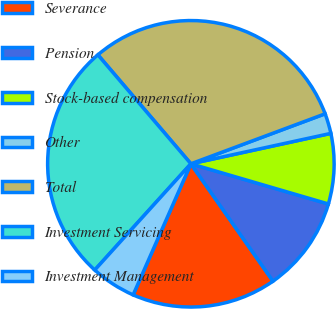<chart> <loc_0><loc_0><loc_500><loc_500><pie_chart><fcel>Severance<fcel>Pension<fcel>Stock-based compensation<fcel>Other<fcel>Total<fcel>Investment Servicing<fcel>Investment Management<nl><fcel>16.32%<fcel>10.76%<fcel>7.93%<fcel>2.27%<fcel>30.57%<fcel>27.05%<fcel>5.1%<nl></chart> 